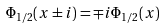<formula> <loc_0><loc_0><loc_500><loc_500>\Phi _ { 1 / 2 } ( x \pm i ) = \mp i \Phi _ { 1 / 2 } ( x )</formula> 